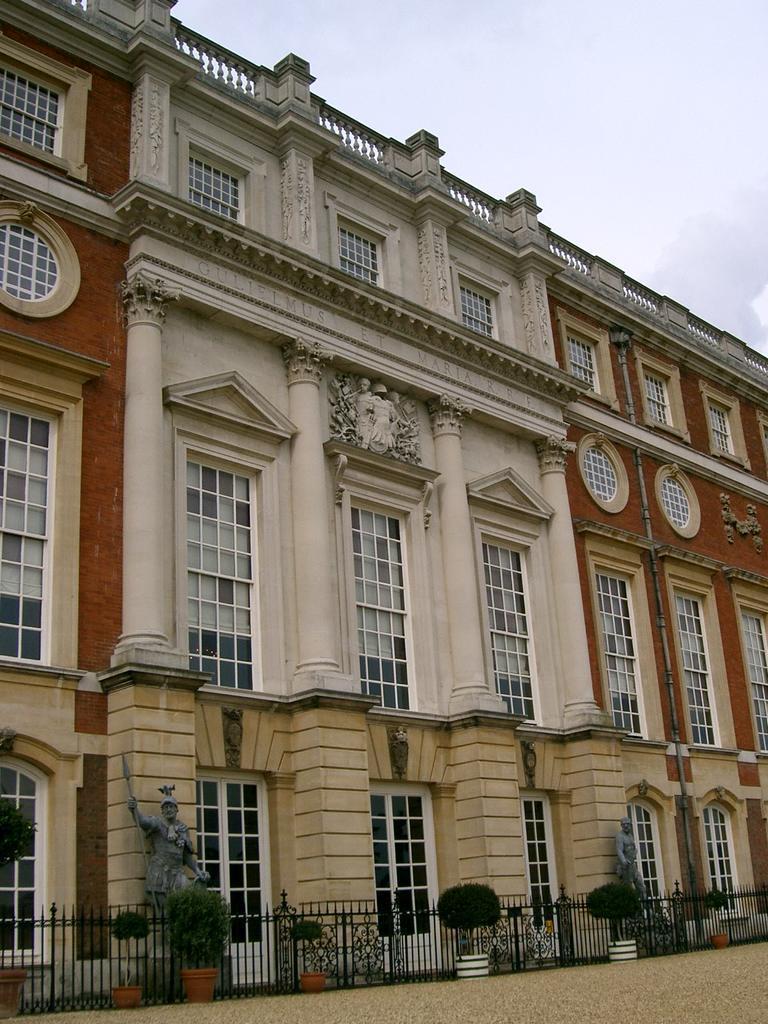Describe this image in one or two sentences. In this image there is the sky towards the top of the image, there is a building, there are windows, there are sculptors, there is a fencing, there are plants, there is a flower pot on the ground, there is a plant towards the left of the image. 